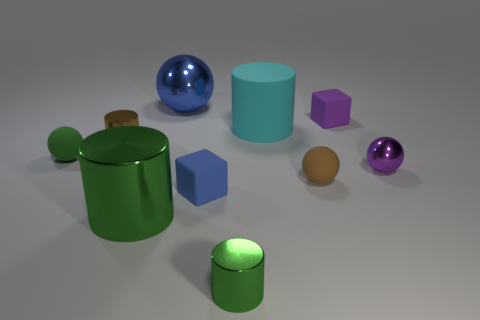Subtract 1 cylinders. How many cylinders are left? 3 Subtract all cylinders. How many objects are left? 6 Subtract all large shiny cylinders. Subtract all small brown shiny cylinders. How many objects are left? 8 Add 3 small purple rubber blocks. How many small purple rubber blocks are left? 4 Add 4 big objects. How many big objects exist? 7 Subtract 0 purple cylinders. How many objects are left? 10 